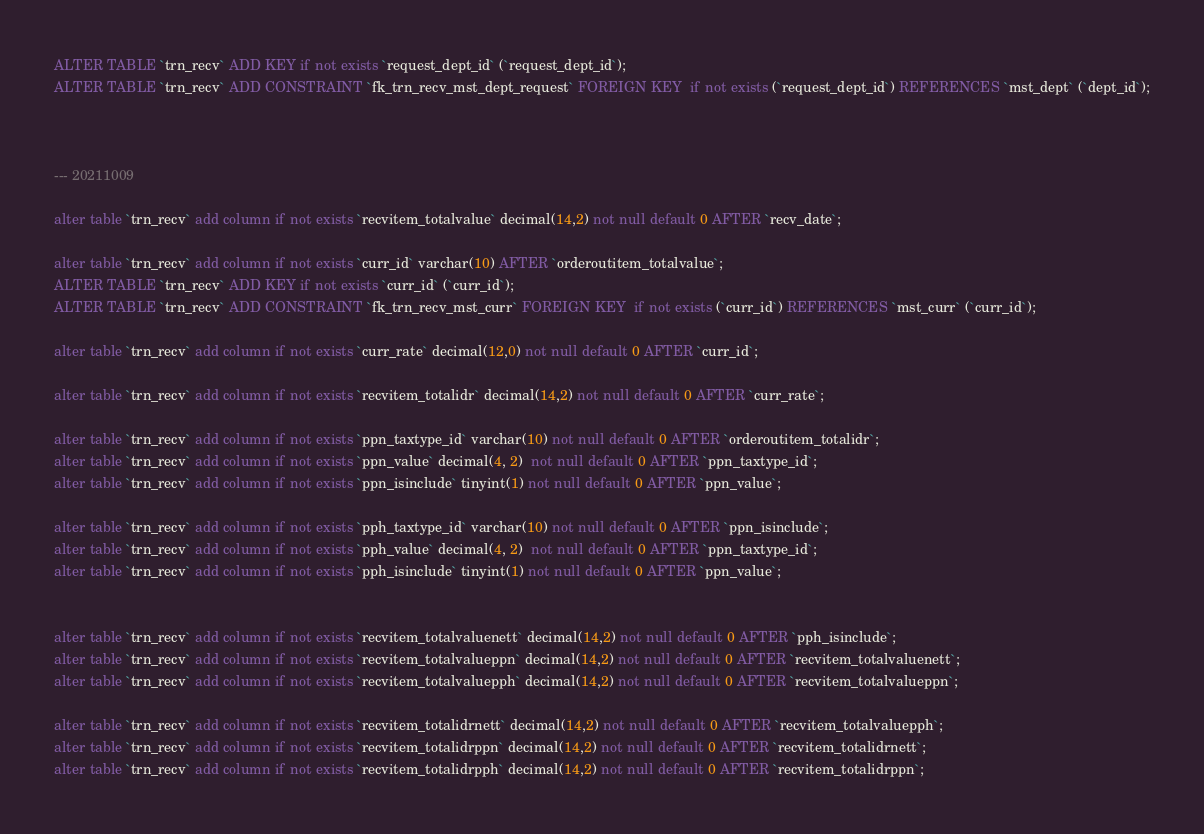<code> <loc_0><loc_0><loc_500><loc_500><_SQL_>ALTER TABLE `trn_recv` ADD KEY if not exists `request_dept_id` (`request_dept_id`);
ALTER TABLE `trn_recv` ADD CONSTRAINT `fk_trn_recv_mst_dept_request` FOREIGN KEY  if not exists (`request_dept_id`) REFERENCES `mst_dept` (`dept_id`);



--- 20211009

alter table `trn_recv` add column if not exists `recvitem_totalvalue` decimal(14,2) not null default 0 AFTER `recv_date`;

alter table `trn_recv` add column if not exists `curr_id` varchar(10) AFTER `orderoutitem_totalvalue`;
ALTER TABLE `trn_recv` ADD KEY if not exists `curr_id` (`curr_id`);
ALTER TABLE `trn_recv` ADD CONSTRAINT `fk_trn_recv_mst_curr` FOREIGN KEY  if not exists (`curr_id`) REFERENCES `mst_curr` (`curr_id`);

alter table `trn_recv` add column if not exists `curr_rate` decimal(12,0) not null default 0 AFTER `curr_id`;

alter table `trn_recv` add column if not exists `recvitem_totalidr` decimal(14,2) not null default 0 AFTER `curr_rate`;

alter table `trn_recv` add column if not exists `ppn_taxtype_id` varchar(10) not null default 0 AFTER `orderoutitem_totalidr`;
alter table `trn_recv` add column if not exists `ppn_value` decimal(4, 2)  not null default 0 AFTER `ppn_taxtype_id`;
alter table `trn_recv` add column if not exists `ppn_isinclude` tinyint(1) not null default 0 AFTER `ppn_value`;

alter table `trn_recv` add column if not exists `pph_taxtype_id` varchar(10) not null default 0 AFTER `ppn_isinclude`;
alter table `trn_recv` add column if not exists `pph_value` decimal(4, 2)  not null default 0 AFTER `ppn_taxtype_id`;
alter table `trn_recv` add column if not exists `pph_isinclude` tinyint(1) not null default 0 AFTER `ppn_value`;


alter table `trn_recv` add column if not exists `recvitem_totalvaluenett` decimal(14,2) not null default 0 AFTER `pph_isinclude`;
alter table `trn_recv` add column if not exists `recvitem_totalvalueppn` decimal(14,2) not null default 0 AFTER `recvitem_totalvaluenett`;
alter table `trn_recv` add column if not exists `recvitem_totalvaluepph` decimal(14,2) not null default 0 AFTER `recvitem_totalvalueppn`;

alter table `trn_recv` add column if not exists `recvitem_totalidrnett` decimal(14,2) not null default 0 AFTER `recvitem_totalvaluepph`;
alter table `trn_recv` add column if not exists `recvitem_totalidrppn` decimal(14,2) not null default 0 AFTER `recvitem_totalidrnett`;
alter table `trn_recv` add column if not exists `recvitem_totalidrpph` decimal(14,2) not null default 0 AFTER `recvitem_totalidrppn`;








</code> 